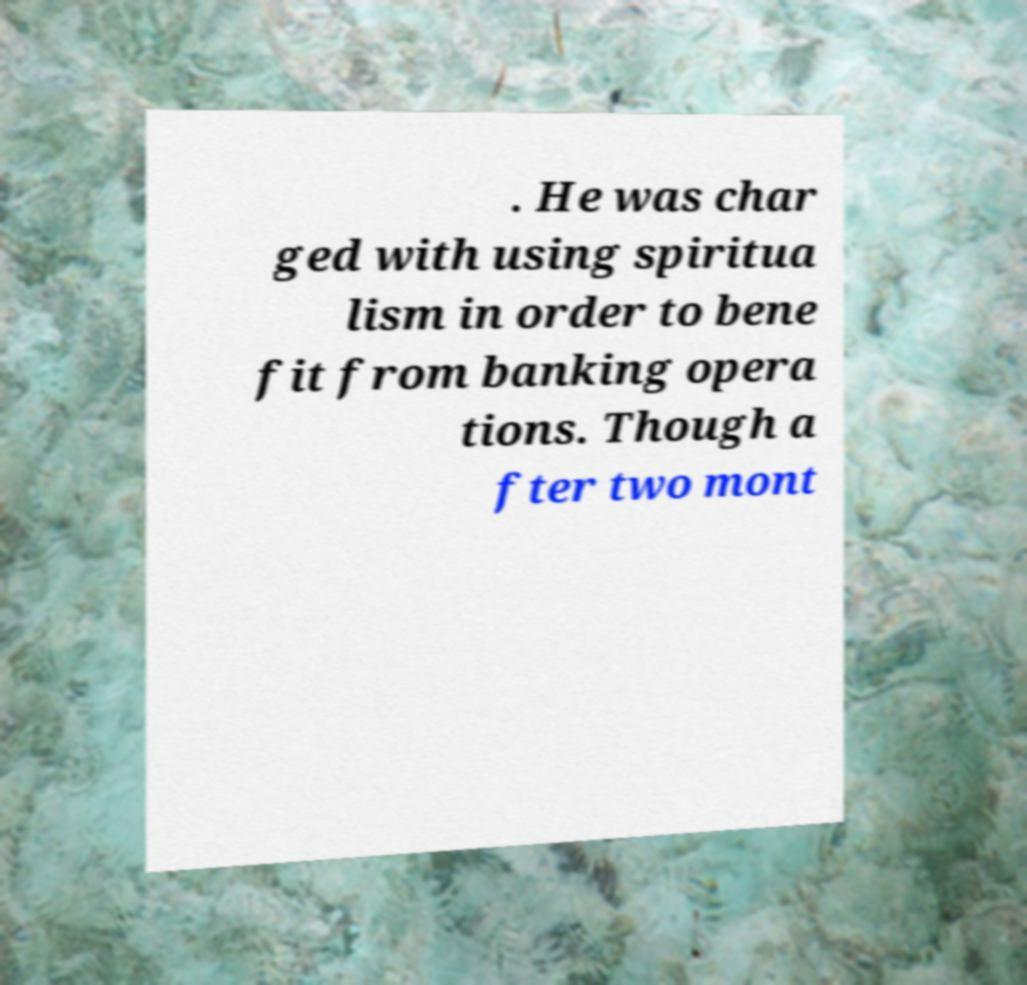Could you extract and type out the text from this image? . He was char ged with using spiritua lism in order to bene fit from banking opera tions. Though a fter two mont 